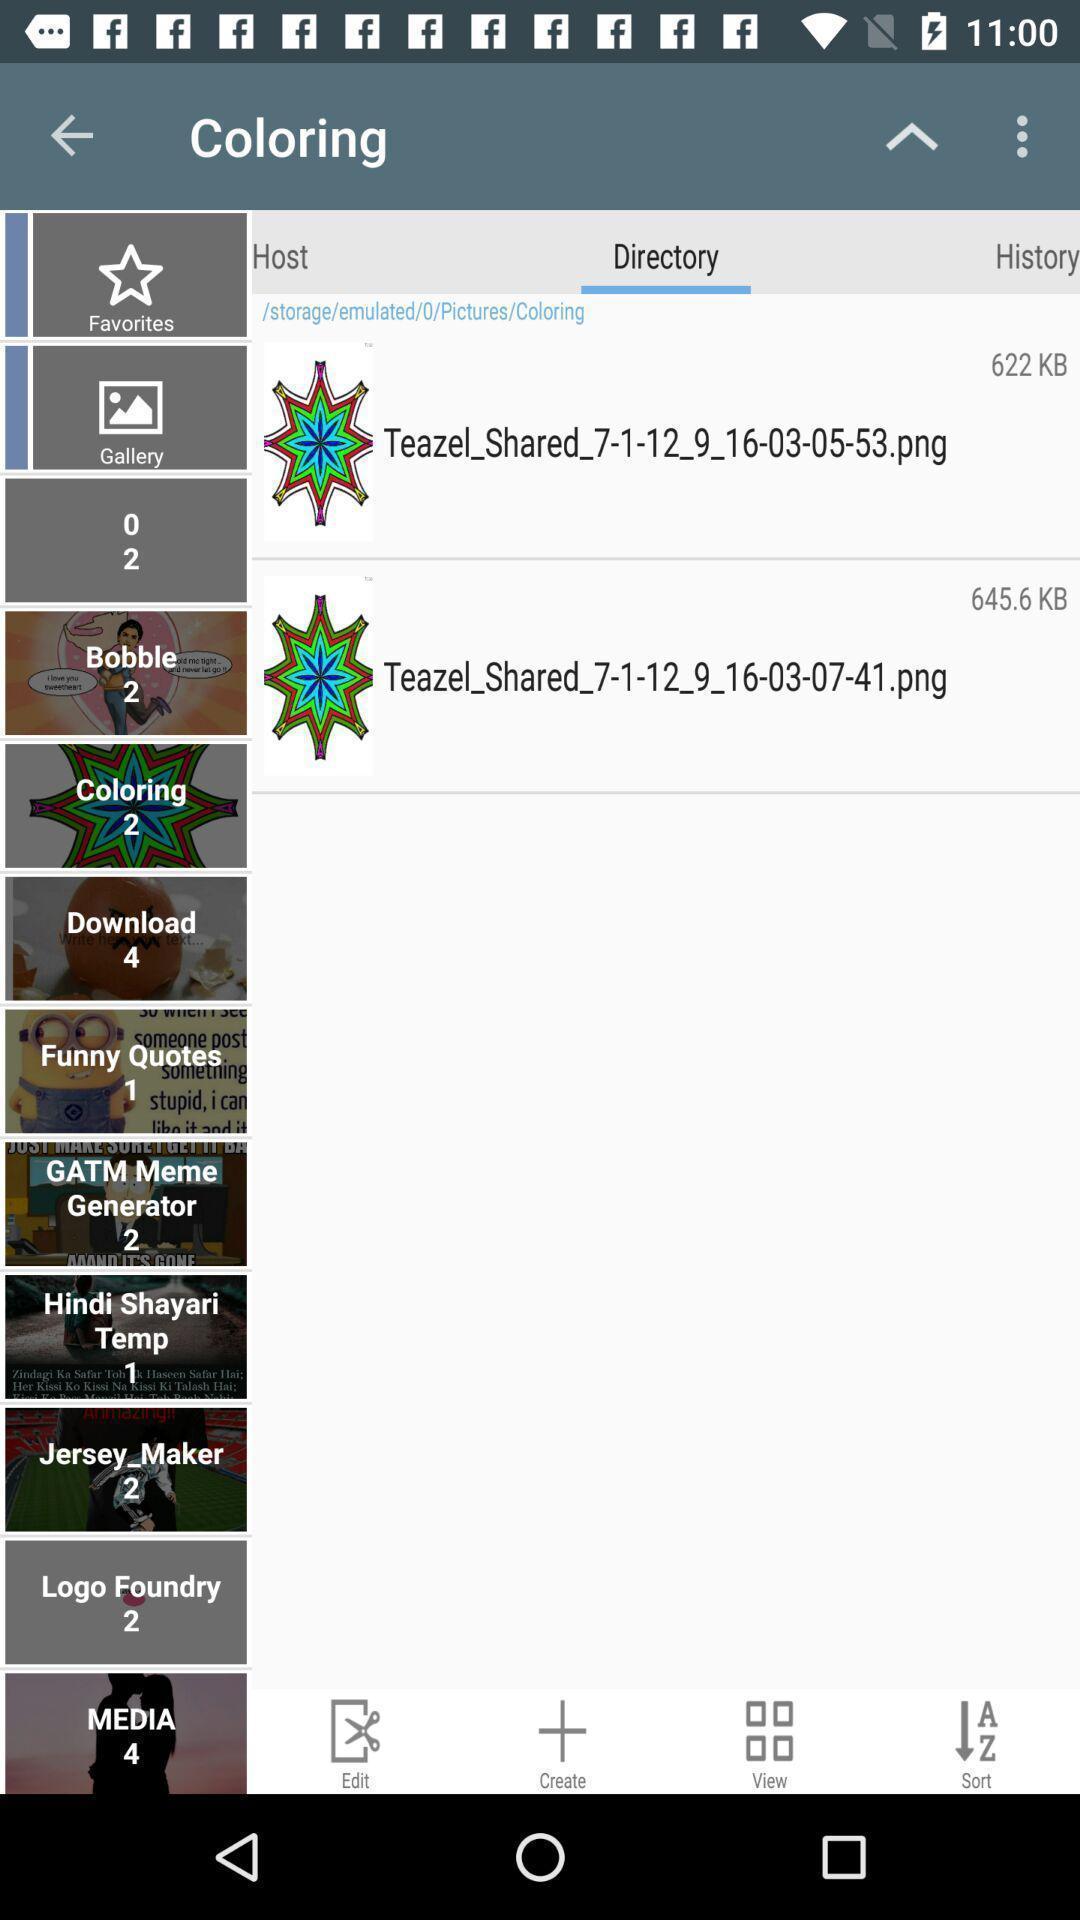Provide a detailed account of this screenshot. Page displaying files. 